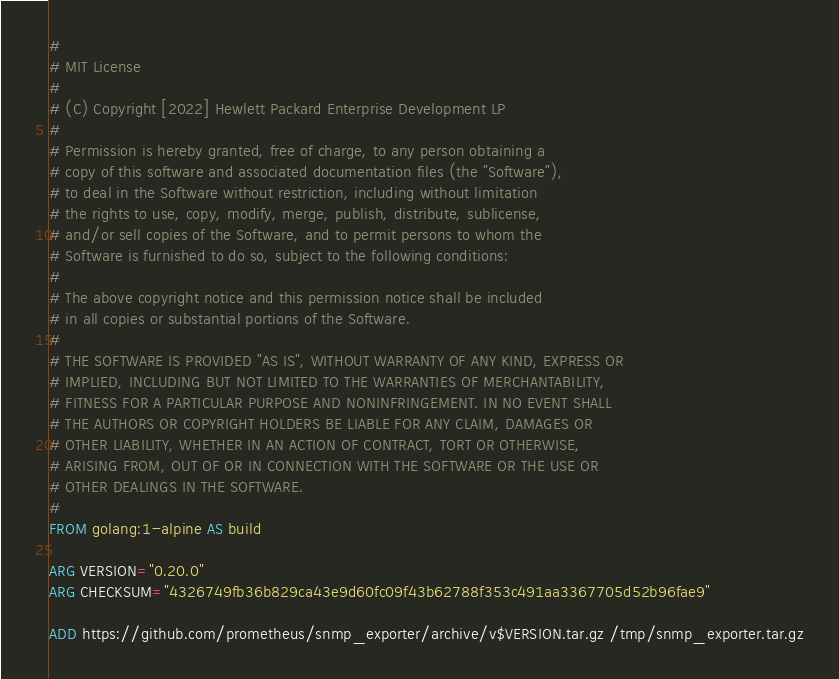<code> <loc_0><loc_0><loc_500><loc_500><_Dockerfile_>#
# MIT License
#
# (C) Copyright [2022] Hewlett Packard Enterprise Development LP
#
# Permission is hereby granted, free of charge, to any person obtaining a
# copy of this software and associated documentation files (the "Software"),
# to deal in the Software without restriction, including without limitation
# the rights to use, copy, modify, merge, publish, distribute, sublicense,
# and/or sell copies of the Software, and to permit persons to whom the
# Software is furnished to do so, subject to the following conditions:
#
# The above copyright notice and this permission notice shall be included
# in all copies or substantial portions of the Software.
#
# THE SOFTWARE IS PROVIDED "AS IS", WITHOUT WARRANTY OF ANY KIND, EXPRESS OR
# IMPLIED, INCLUDING BUT NOT LIMITED TO THE WARRANTIES OF MERCHANTABILITY,
# FITNESS FOR A PARTICULAR PURPOSE AND NONINFRINGEMENT. IN NO EVENT SHALL
# THE AUTHORS OR COPYRIGHT HOLDERS BE LIABLE FOR ANY CLAIM, DAMAGES OR
# OTHER LIABILITY, WHETHER IN AN ACTION OF CONTRACT, TORT OR OTHERWISE,
# ARISING FROM, OUT OF OR IN CONNECTION WITH THE SOFTWARE OR THE USE OR
# OTHER DEALINGS IN THE SOFTWARE.
#
FROM golang:1-alpine AS build

ARG VERSION="0.20.0"
ARG CHECKSUM="4326749fb36b829ca43e9d60fc09f43b62788f353c491aa3367705d52b96fae9"

ADD https://github.com/prometheus/snmp_exporter/archive/v$VERSION.tar.gz /tmp/snmp_exporter.tar.gz
</code> 